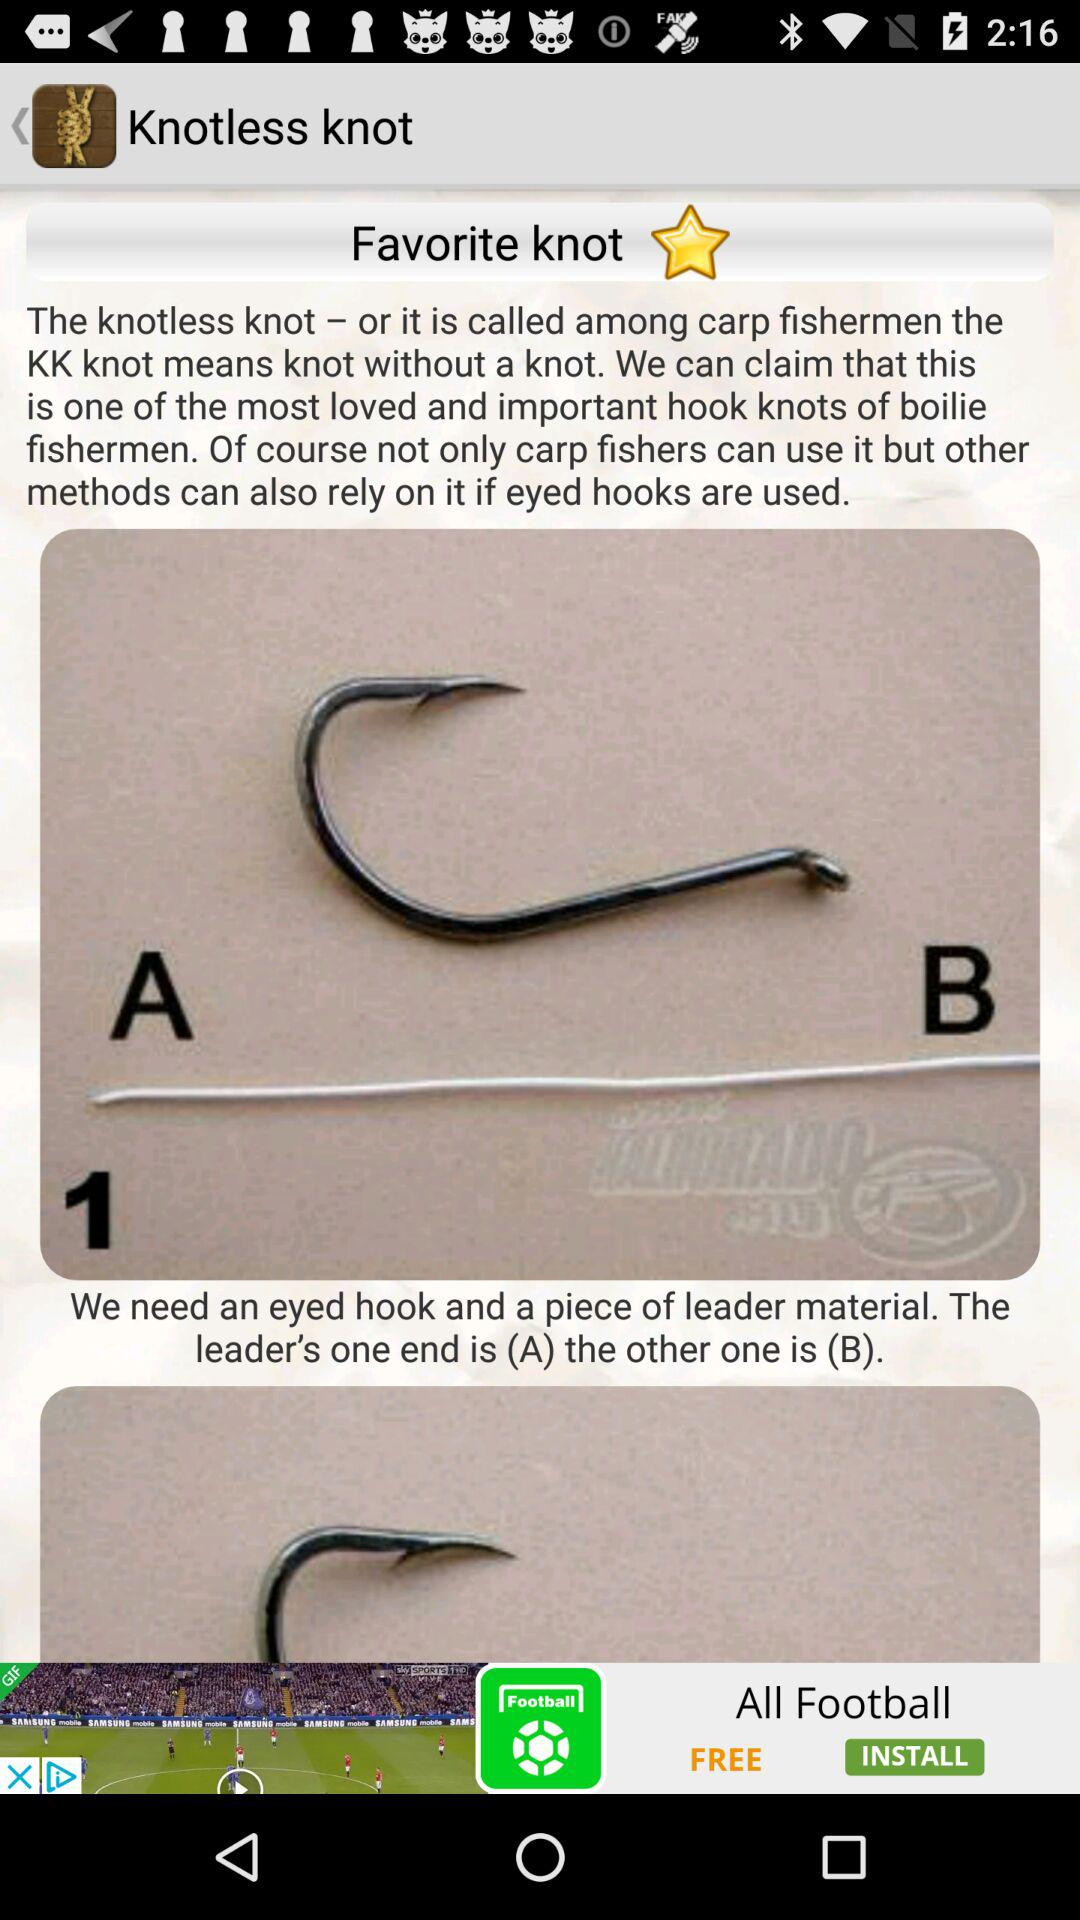What is the application name?
When the provided information is insufficient, respond with <no answer>. <no answer> 